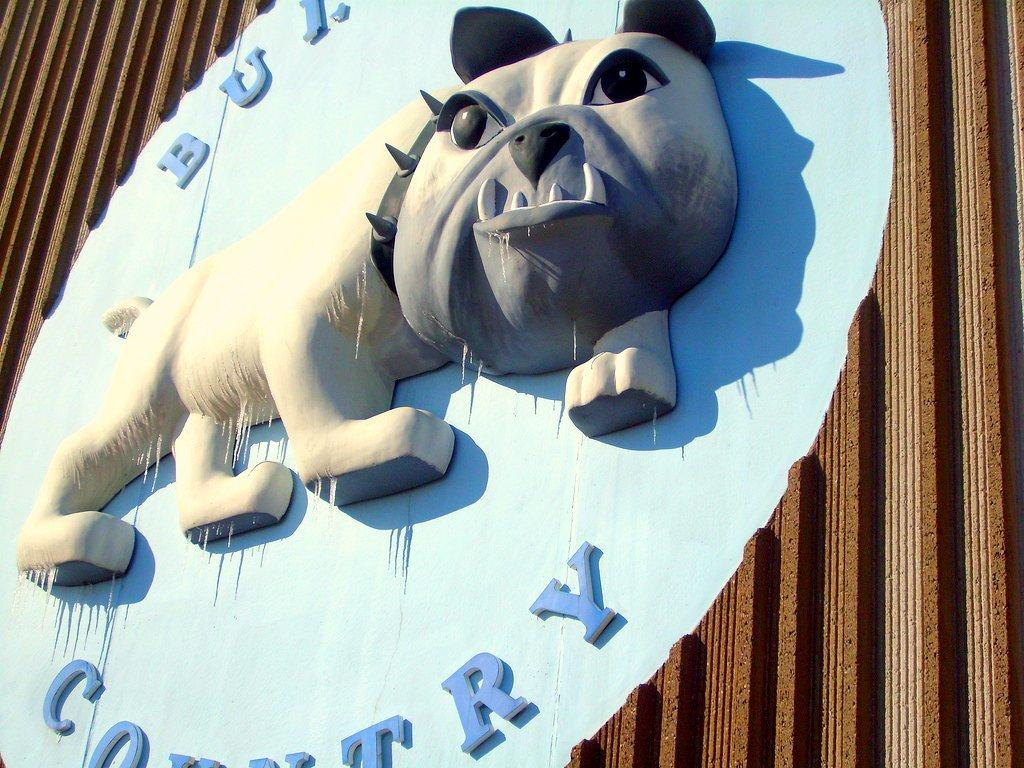What is the main object in the image? There is a board in the image. What is the board placed on? The board is on a wooden object. What type of waste is visible on the ground in the image? There is no mention of waste or ground in the provided facts, so we cannot answer this question based on the image. 